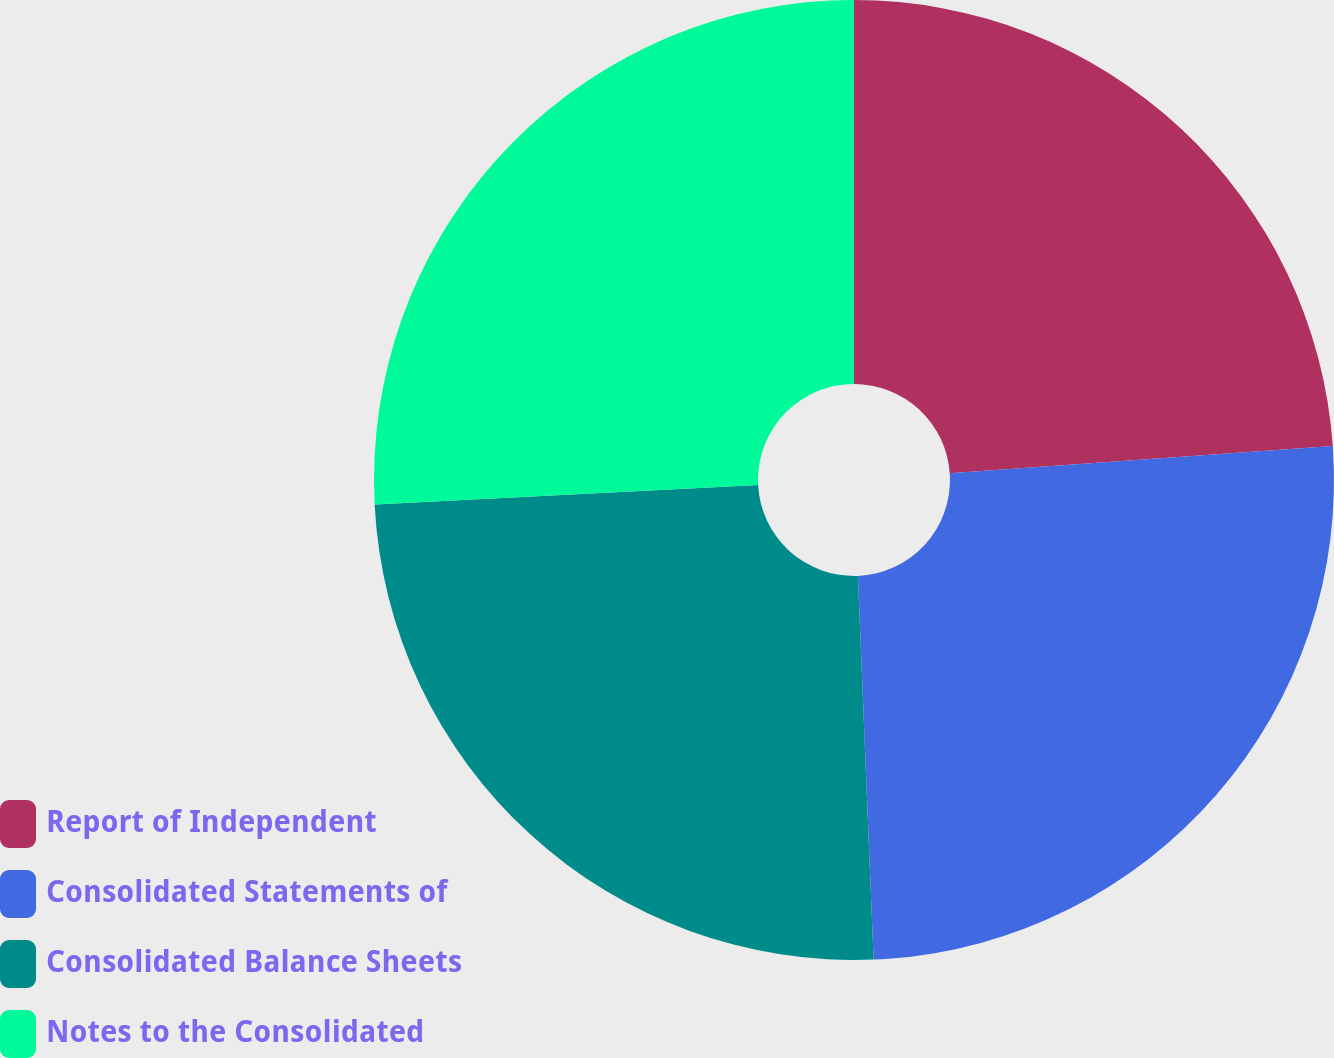Convert chart to OTSL. <chart><loc_0><loc_0><loc_500><loc_500><pie_chart><fcel>Report of Independent<fcel>Consolidated Statements of<fcel>Consolidated Balance Sheets<fcel>Notes to the Consolidated<nl><fcel>23.87%<fcel>25.48%<fcel>24.84%<fcel>25.81%<nl></chart> 